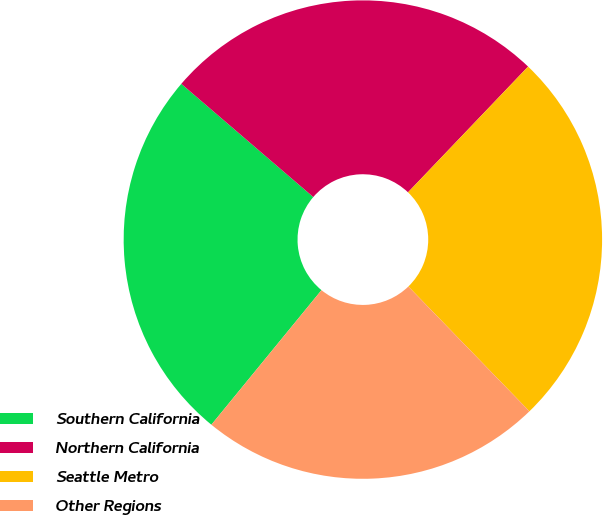Convert chart to OTSL. <chart><loc_0><loc_0><loc_500><loc_500><pie_chart><fcel>Southern California<fcel>Northern California<fcel>Seattle Metro<fcel>Other Regions<nl><fcel>25.37%<fcel>25.85%<fcel>25.61%<fcel>23.17%<nl></chart> 